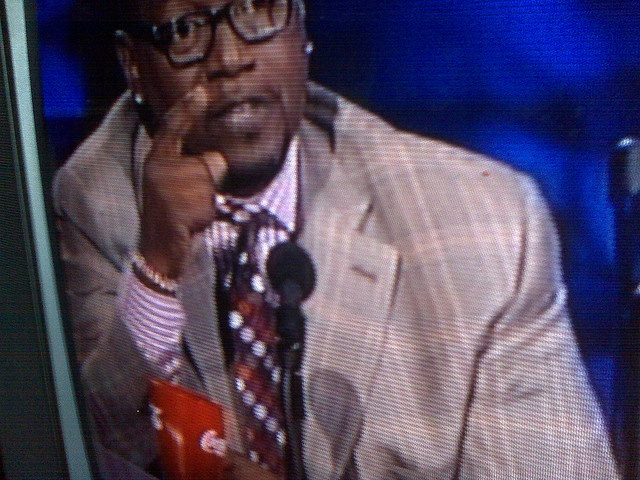Describe the objects in this image and their specific colors. I can see people in black, darkgray, gray, and maroon tones, tie in black, maroon, and purple tones, and cup in black, maroon, and brown tones in this image. 